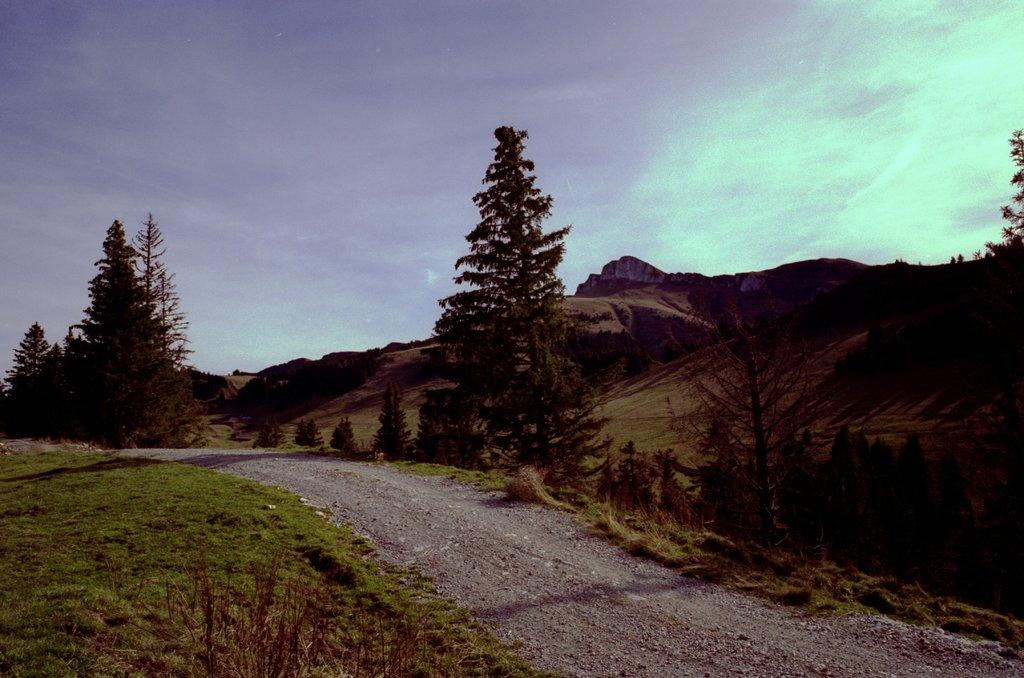What type of vegetation is present in the image? There is grass and trees in the image. What other natural elements can be seen in the image? There are rocks in the image. How many quarters are hidden among the rocks in the image? There are no quarters present in the image; it only features grass, trees, and rocks. 